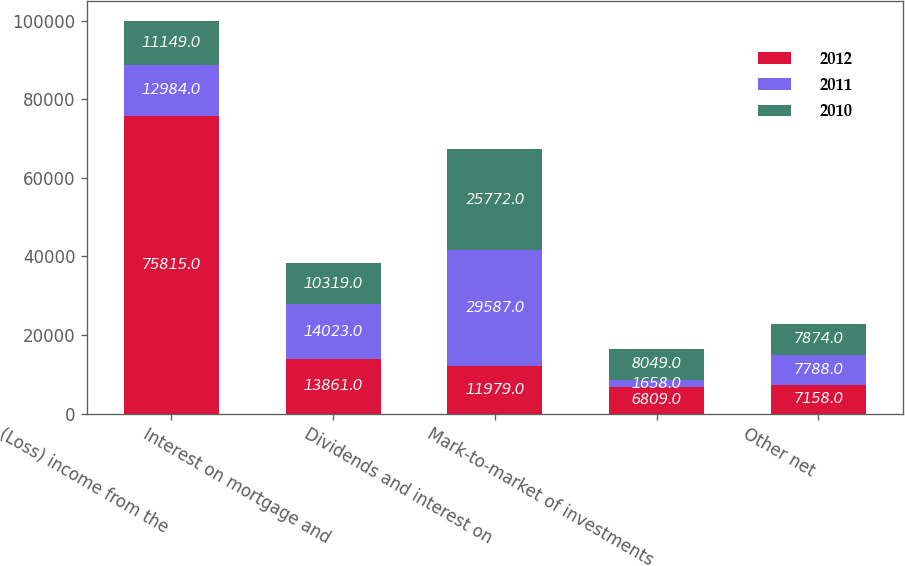Convert chart to OTSL. <chart><loc_0><loc_0><loc_500><loc_500><stacked_bar_chart><ecel><fcel>(Loss) income from the<fcel>Interest on mortgage and<fcel>Dividends and interest on<fcel>Mark-to-market of investments<fcel>Other net<nl><fcel>2012<fcel>75815<fcel>13861<fcel>11979<fcel>6809<fcel>7158<nl><fcel>2011<fcel>12984<fcel>14023<fcel>29587<fcel>1658<fcel>7788<nl><fcel>2010<fcel>11149<fcel>10319<fcel>25772<fcel>8049<fcel>7874<nl></chart> 